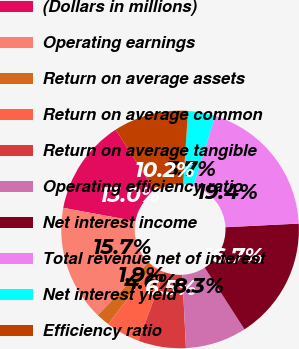<chart> <loc_0><loc_0><loc_500><loc_500><pie_chart><fcel>(Dollars in millions)<fcel>Operating earnings<fcel>Return on average assets<fcel>Return on average common<fcel>Return on average tangible<fcel>Operating efficiency ratio<fcel>Net interest income<fcel>Total revenue net of interest<fcel>Net interest yield<fcel>Efficiency ratio<nl><fcel>12.96%<fcel>15.74%<fcel>1.85%<fcel>4.63%<fcel>6.48%<fcel>8.33%<fcel>16.67%<fcel>19.44%<fcel>3.7%<fcel>10.19%<nl></chart> 